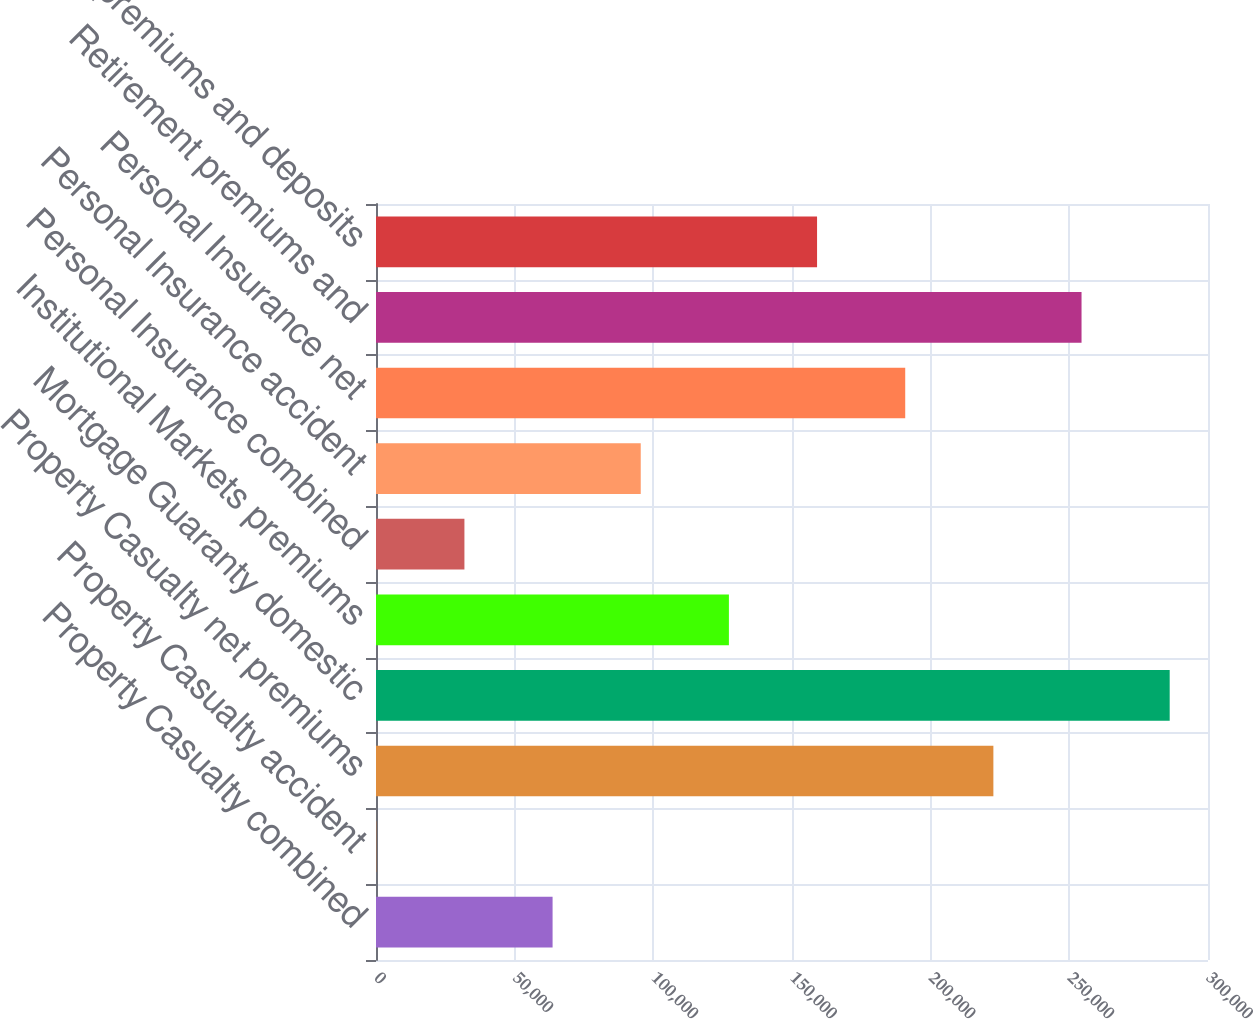Convert chart to OTSL. <chart><loc_0><loc_0><loc_500><loc_500><bar_chart><fcel>Property Casualty combined<fcel>Property Casualty accident<fcel>Property Casualty net premiums<fcel>Mortgage Guaranty domestic<fcel>Institutional Markets premiums<fcel>Personal Insurance combined<fcel>Personal Insurance accident<fcel>Personal Insurance net<fcel>Retirement premiums and<fcel>Life premiums and deposits<nl><fcel>63671.5<fcel>95.1<fcel>222612<fcel>286189<fcel>127248<fcel>31883.3<fcel>95459.7<fcel>190824<fcel>254401<fcel>159036<nl></chart> 